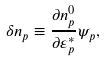Convert formula to latex. <formula><loc_0><loc_0><loc_500><loc_500>\delta n _ { p } \equiv \frac { \partial n ^ { 0 } _ { p } } { \partial \varepsilon ^ { * } _ { p } } \psi _ { p } ,</formula> 